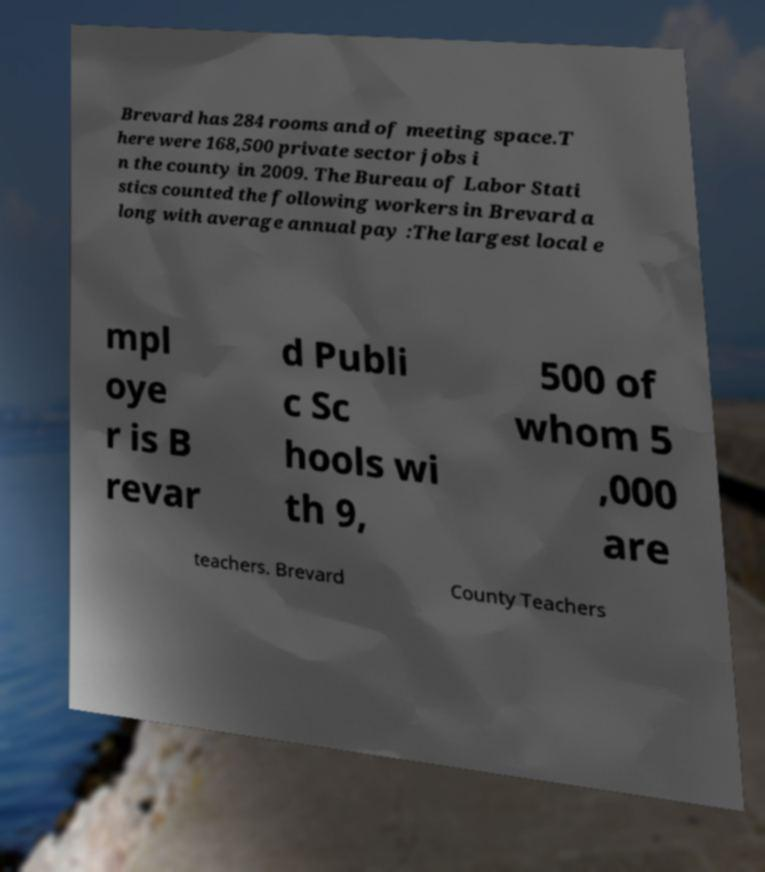I need the written content from this picture converted into text. Can you do that? Brevard has 284 rooms and of meeting space.T here were 168,500 private sector jobs i n the county in 2009. The Bureau of Labor Stati stics counted the following workers in Brevard a long with average annual pay :The largest local e mpl oye r is B revar d Publi c Sc hools wi th 9, 500 of whom 5 ,000 are teachers. Brevard County Teachers 